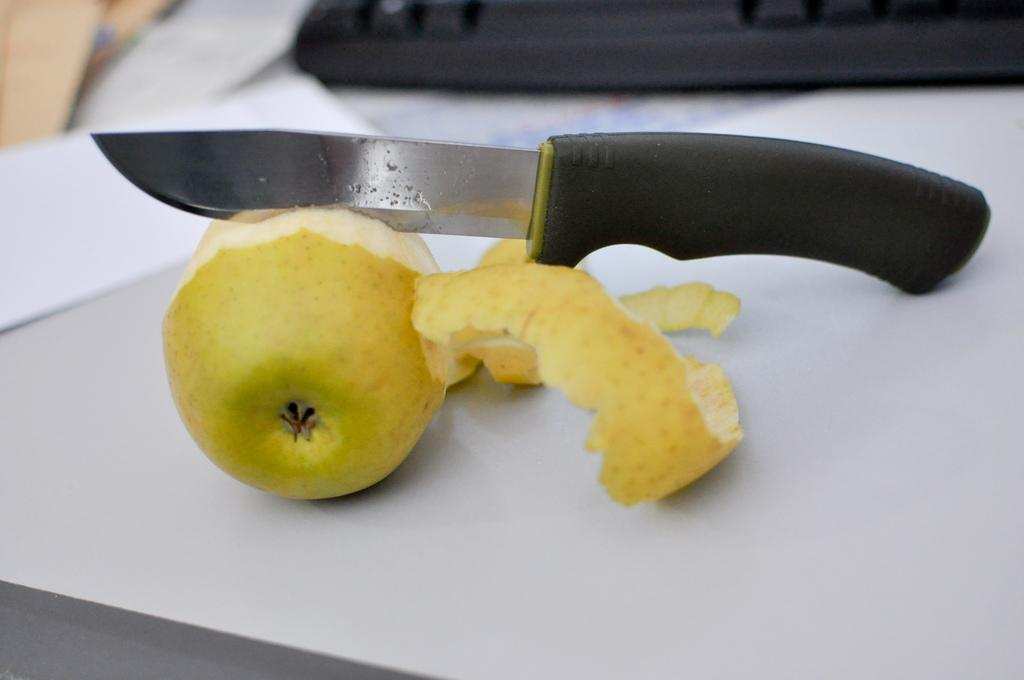What type of food is present in the image? There is a fruit in the image. How is the fruit prepared? The fruit is cut. What tool is used to cut the fruit? There is a knife in the image. How many frogs are sitting on the wire in the image? There are no frogs or wires present in the image. What type of crack is visible in the fruit? The image does not show any cracks in the fruit. 